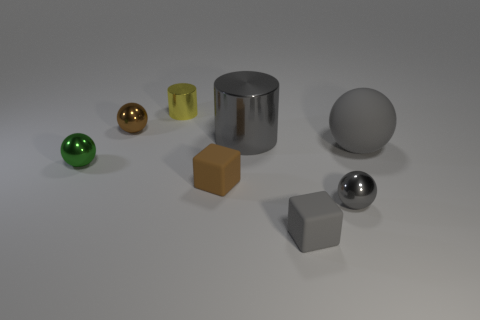Subtract all gray balls. Subtract all gray blocks. How many balls are left? 2 Add 2 rubber balls. How many objects exist? 10 Subtract all cylinders. How many objects are left? 6 Subtract all tiny yellow shiny cylinders. Subtract all large balls. How many objects are left? 6 Add 6 small shiny balls. How many small shiny balls are left? 9 Add 7 green shiny balls. How many green shiny balls exist? 8 Subtract 0 red cubes. How many objects are left? 8 